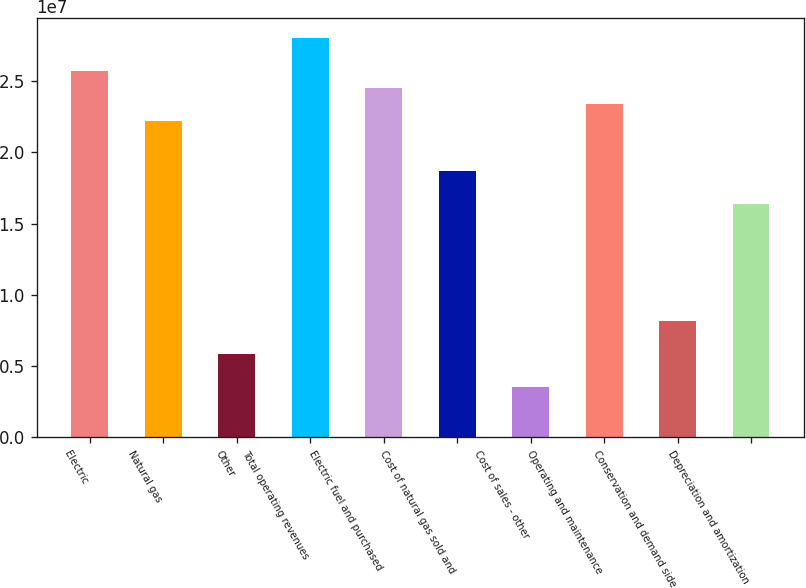<chart> <loc_0><loc_0><loc_500><loc_500><bar_chart><fcel>Electric<fcel>Natural gas<fcel>Other<fcel>Total operating revenues<fcel>Electric fuel and purchased<fcel>Cost of natural gas sold and<fcel>Cost of sales - other<fcel>Operating and maintenance<fcel>Conservation and demand side<fcel>Depreciation and amortization<nl><fcel>2.57095e+07<fcel>2.22037e+07<fcel>5.84307e+06<fcel>2.80467e+07<fcel>2.45409e+07<fcel>1.86978e+07<fcel>3.50584e+06<fcel>2.33723e+07<fcel>8.18029e+06<fcel>1.63606e+07<nl></chart> 